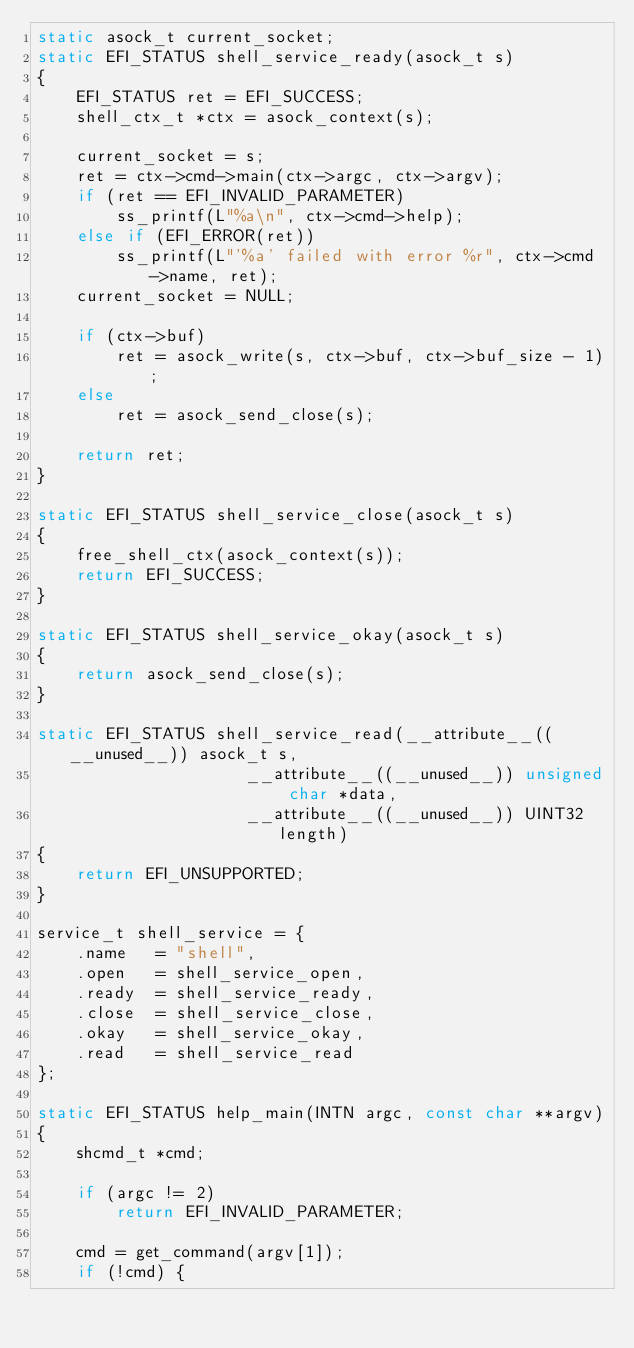Convert code to text. <code><loc_0><loc_0><loc_500><loc_500><_C_>static asock_t current_socket;
static EFI_STATUS shell_service_ready(asock_t s)
{
	EFI_STATUS ret = EFI_SUCCESS;
	shell_ctx_t *ctx = asock_context(s);

	current_socket = s;
	ret = ctx->cmd->main(ctx->argc, ctx->argv);
	if (ret == EFI_INVALID_PARAMETER)
		ss_printf(L"%a\n", ctx->cmd->help);
	else if (EFI_ERROR(ret))
		ss_printf(L"'%a' failed with error %r", ctx->cmd->name, ret);
	current_socket = NULL;

	if (ctx->buf)
		ret = asock_write(s, ctx->buf, ctx->buf_size - 1);
	else
		ret = asock_send_close(s);

	return ret;
}

static EFI_STATUS shell_service_close(asock_t s)
{
	free_shell_ctx(asock_context(s));
	return EFI_SUCCESS;
}

static EFI_STATUS shell_service_okay(asock_t s)
{
	return asock_send_close(s);
}

static EFI_STATUS shell_service_read(__attribute__((__unused__)) asock_t s,
				     __attribute__((__unused__)) unsigned char *data,
				     __attribute__((__unused__)) UINT32 length)
{
	return EFI_UNSUPPORTED;
}

service_t shell_service = {
	.name	= "shell",
	.open	= shell_service_open,
	.ready	= shell_service_ready,
	.close	= shell_service_close,
	.okay	= shell_service_okay,
	.read	= shell_service_read
};

static EFI_STATUS help_main(INTN argc, const char **argv)
{
	shcmd_t *cmd;

	if (argc != 2)
		return EFI_INVALID_PARAMETER;

	cmd = get_command(argv[1]);
	if (!cmd) {</code> 